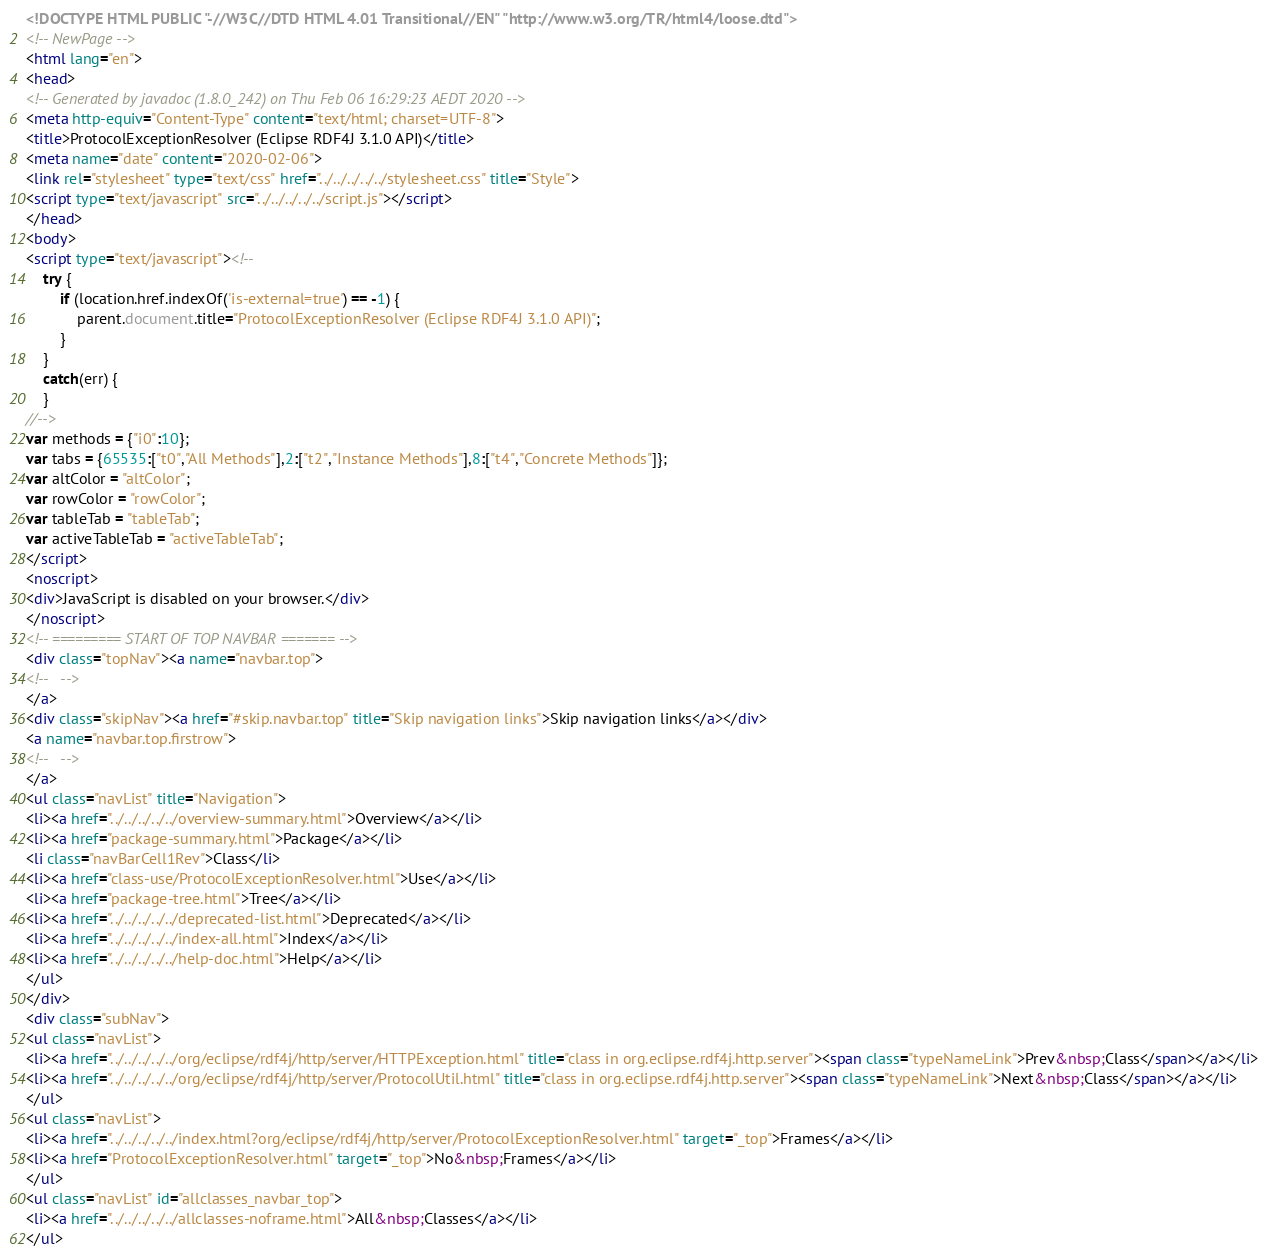<code> <loc_0><loc_0><loc_500><loc_500><_HTML_><!DOCTYPE HTML PUBLIC "-//W3C//DTD HTML 4.01 Transitional//EN" "http://www.w3.org/TR/html4/loose.dtd">
<!-- NewPage -->
<html lang="en">
<head>
<!-- Generated by javadoc (1.8.0_242) on Thu Feb 06 16:29:23 AEDT 2020 -->
<meta http-equiv="Content-Type" content="text/html; charset=UTF-8">
<title>ProtocolExceptionResolver (Eclipse RDF4J 3.1.0 API)</title>
<meta name="date" content="2020-02-06">
<link rel="stylesheet" type="text/css" href="../../../../../stylesheet.css" title="Style">
<script type="text/javascript" src="../../../../../script.js"></script>
</head>
<body>
<script type="text/javascript"><!--
    try {
        if (location.href.indexOf('is-external=true') == -1) {
            parent.document.title="ProtocolExceptionResolver (Eclipse RDF4J 3.1.0 API)";
        }
    }
    catch(err) {
    }
//-->
var methods = {"i0":10};
var tabs = {65535:["t0","All Methods"],2:["t2","Instance Methods"],8:["t4","Concrete Methods"]};
var altColor = "altColor";
var rowColor = "rowColor";
var tableTab = "tableTab";
var activeTableTab = "activeTableTab";
</script>
<noscript>
<div>JavaScript is disabled on your browser.</div>
</noscript>
<!-- ========= START OF TOP NAVBAR ======= -->
<div class="topNav"><a name="navbar.top">
<!--   -->
</a>
<div class="skipNav"><a href="#skip.navbar.top" title="Skip navigation links">Skip navigation links</a></div>
<a name="navbar.top.firstrow">
<!--   -->
</a>
<ul class="navList" title="Navigation">
<li><a href="../../../../../overview-summary.html">Overview</a></li>
<li><a href="package-summary.html">Package</a></li>
<li class="navBarCell1Rev">Class</li>
<li><a href="class-use/ProtocolExceptionResolver.html">Use</a></li>
<li><a href="package-tree.html">Tree</a></li>
<li><a href="../../../../../deprecated-list.html">Deprecated</a></li>
<li><a href="../../../../../index-all.html">Index</a></li>
<li><a href="../../../../../help-doc.html">Help</a></li>
</ul>
</div>
<div class="subNav">
<ul class="navList">
<li><a href="../../../../../org/eclipse/rdf4j/http/server/HTTPException.html" title="class in org.eclipse.rdf4j.http.server"><span class="typeNameLink">Prev&nbsp;Class</span></a></li>
<li><a href="../../../../../org/eclipse/rdf4j/http/server/ProtocolUtil.html" title="class in org.eclipse.rdf4j.http.server"><span class="typeNameLink">Next&nbsp;Class</span></a></li>
</ul>
<ul class="navList">
<li><a href="../../../../../index.html?org/eclipse/rdf4j/http/server/ProtocolExceptionResolver.html" target="_top">Frames</a></li>
<li><a href="ProtocolExceptionResolver.html" target="_top">No&nbsp;Frames</a></li>
</ul>
<ul class="navList" id="allclasses_navbar_top">
<li><a href="../../../../../allclasses-noframe.html">All&nbsp;Classes</a></li>
</ul></code> 